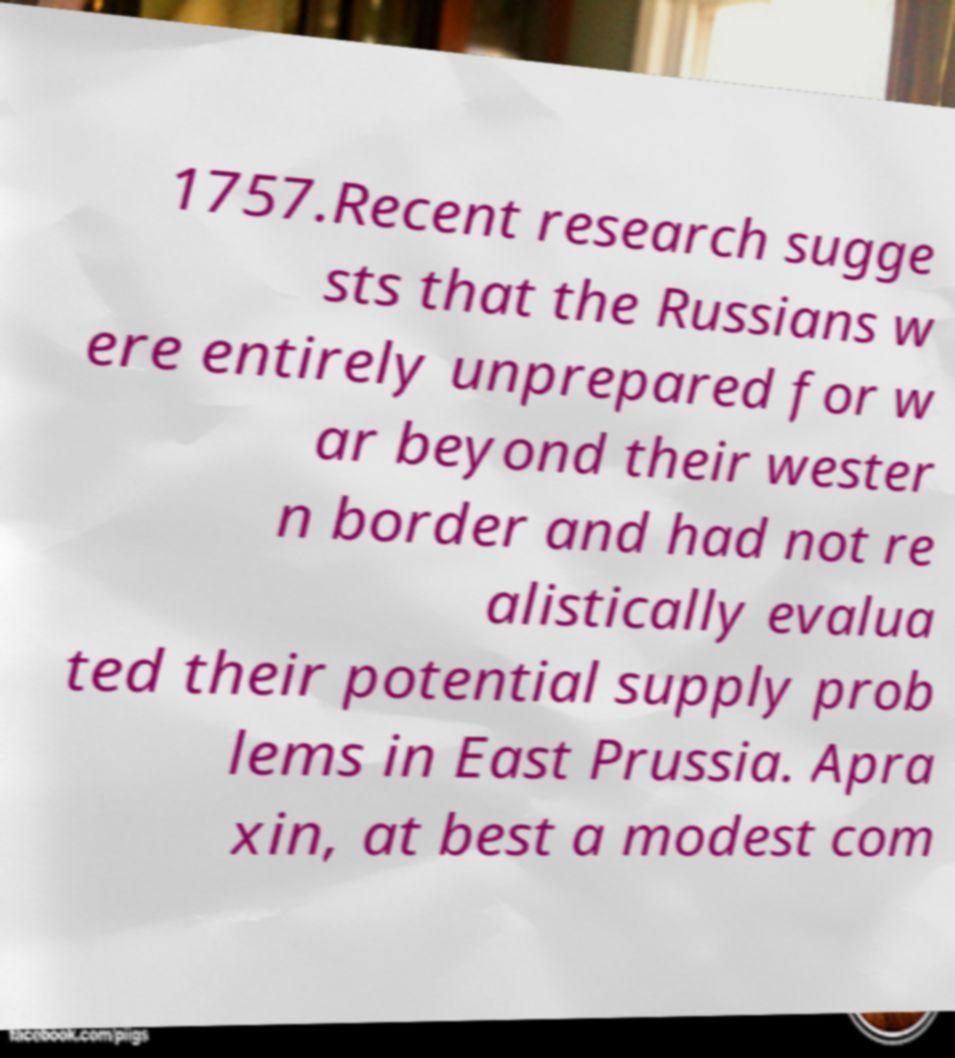There's text embedded in this image that I need extracted. Can you transcribe it verbatim? 1757.Recent research sugge sts that the Russians w ere entirely unprepared for w ar beyond their wester n border and had not re alistically evalua ted their potential supply prob lems in East Prussia. Apra xin, at best a modest com 